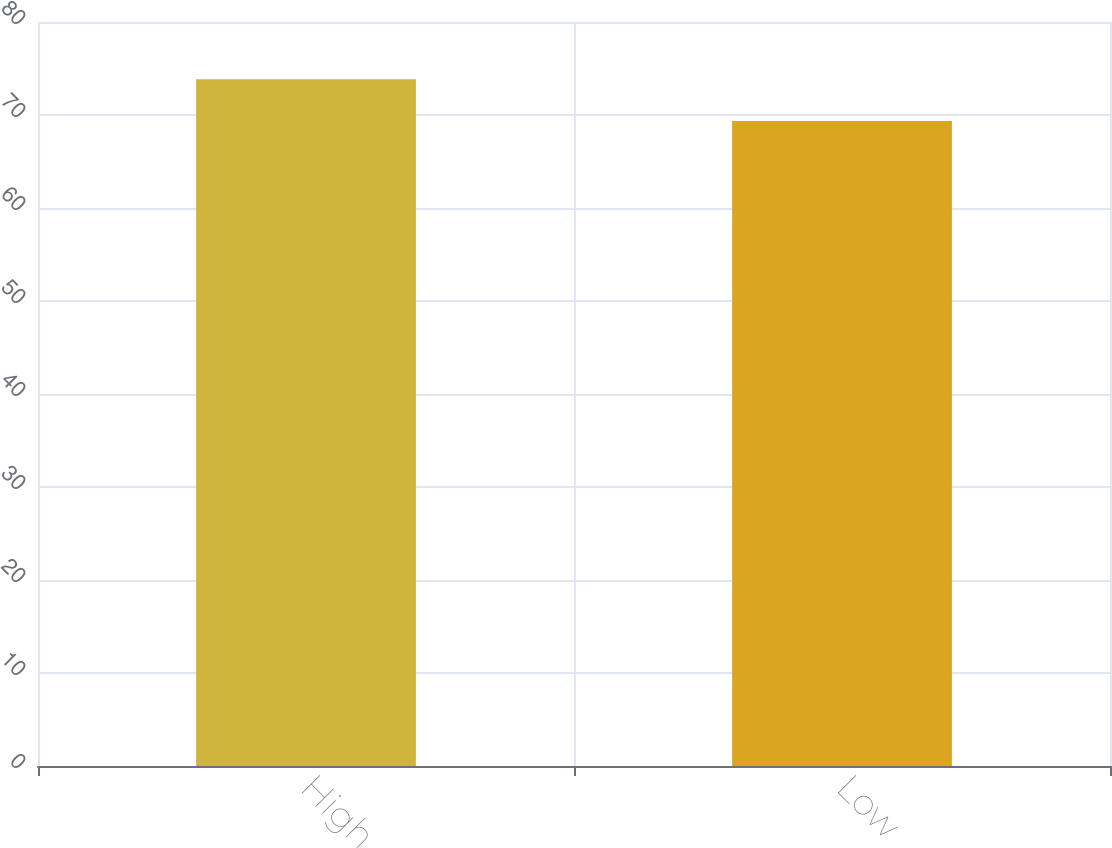<chart> <loc_0><loc_0><loc_500><loc_500><bar_chart><fcel>High<fcel>Low<nl><fcel>73.84<fcel>69.36<nl></chart> 